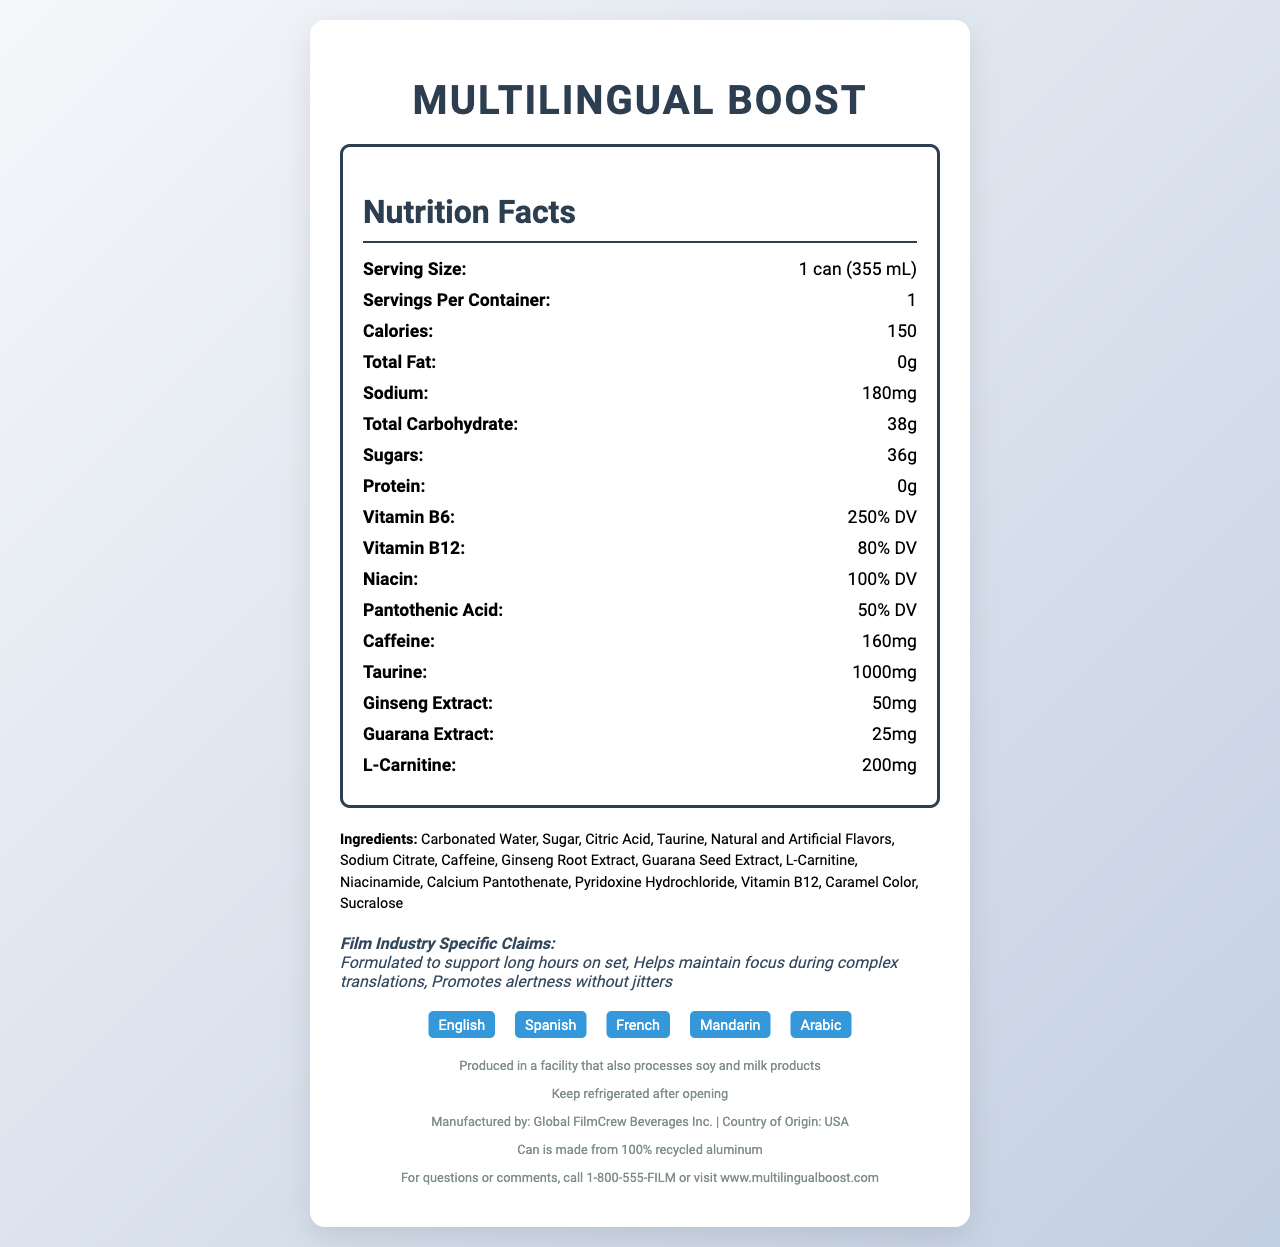what is the serving size? The serving size is indicated in the "Nutrition Facts" section of the document as "1 can (355 mL)".
Answer: 1 can (355 mL) how much caffeine is in one serving? The amount of caffeine is listed in the "Nutrition Facts" section under "Caffeine" as 160 mg.
Answer: 160 mg how many servings are in one container? The servings per container are noted in the "Nutrition Facts" section as 1.
Answer: 1 what are some of the ingredients in MultiLingual Boost? The full list of ingredients is found in the "Ingredients" section.
Answer: Carbonated Water, Sugar, Citric Acid, Taurine, Natural and Artificial Flavors, Sodium Citrate, Caffeine what specific claims are made about MultiLingual Boost for the film industry? These claims are detailed in the "Film Industry Specific Claims" section.
Answer: Formulated to support long hours on set, Helps maintain focus during complex translations, Promotes alertness without jitters how much Vitamin B6 is in this drink? The Vitamin B6 content is listed as 250% DV in the "Nutrition Facts" section.
Answer: 250% DV which of the following vitamins is present at 80% of the daily value? A. Vitamin B6 B. Vitamin B12 C. Niacin D. Pantothenic Acid The "Nutrition Facts" section lists Vitamin B12 at 80% DV.
Answer: B where is MultiLingual Boost manufactured? A. Canada B. USA C. France D. China The "Country of Origin" section mentions that the product is manufactured in the USA.
Answer: B is MultiLingual Boost sugar-free? The "Nutrition Facts" section lists sugars as 36g, so it is not sugar-free.
Answer: No should MultiLingual Boost be kept refrigerated after opening? The "Storage Instructions" section advises to keep refrigerated after opening.
Answer: Yes summarize the main points of the document. The document displays nutritional facts, ingredients, storage instructions, and film industry-specific claims. It also notes the product’s sustainability, allergen information, and contact details, making it useful for multilingual film crews needing a boost during long hours.
Answer: The document provides detailed nutritional information about the energy drink "MultiLingual Boost," including serving size, calorie content, and ingredients. It cites specific claims for film industry professionals, mentions that the product is manufactured in the USA, and includes information in multiple languages. which languages are displayed on the label of MultiLingual Boost? The "Languages on Label" section lists all these languages.
Answer: English, Spanish, French, Mandarin, Arabic what is the sodium content of MultiLingual Boost? The sodium content is listed in the "Nutrition Facts" section under "Sodium" as 180 mg.
Answer: 180 mg how many grams of protein does this energy drink contain? The "Nutrition Facts" section notes that the protein content is 0 g.
Answer: 0 g what is the manufacturer of MultiLingual Boost? This information is provided in the "Manufacturer" section toward the bottom of the document.
Answer: Global FilmCrew Beverages Inc. is the can of MultiLingual Boost environmentally friendly? The "Sustainability Info" section states that the can is made from 100% recycled aluminum.
Answer: Yes does MultiLingual Boost contain any allergens? This information is under the "Allergen Info" section.
Answer: Produced in a facility that also processes soy and milk products what percentage of the daily value of niacin does MultiLingual Boost provide? The "Nutrition Facts" section lists niacin content as 100% DV.
Answer: 100% DV how much L-Carnitine is present in this drink? The amount of L-Carnitine is listed in the "Nutrition Facts" section under "L-Carnitine" as 200 mg.
Answer: 200 mg what is the main ingredient of MultiLingual Boost? The first ingredient listed in the "Ingredients" section is Carbonated Water, indicating it is the main ingredient.
Answer: Carbonated Water how does MultiLingual Boost claim to help film crews? The specific effects on film crews are not directly indicated by most of the nutritional information provided, though general claims for energy and focus are made.
Answer: Cannot be determined 